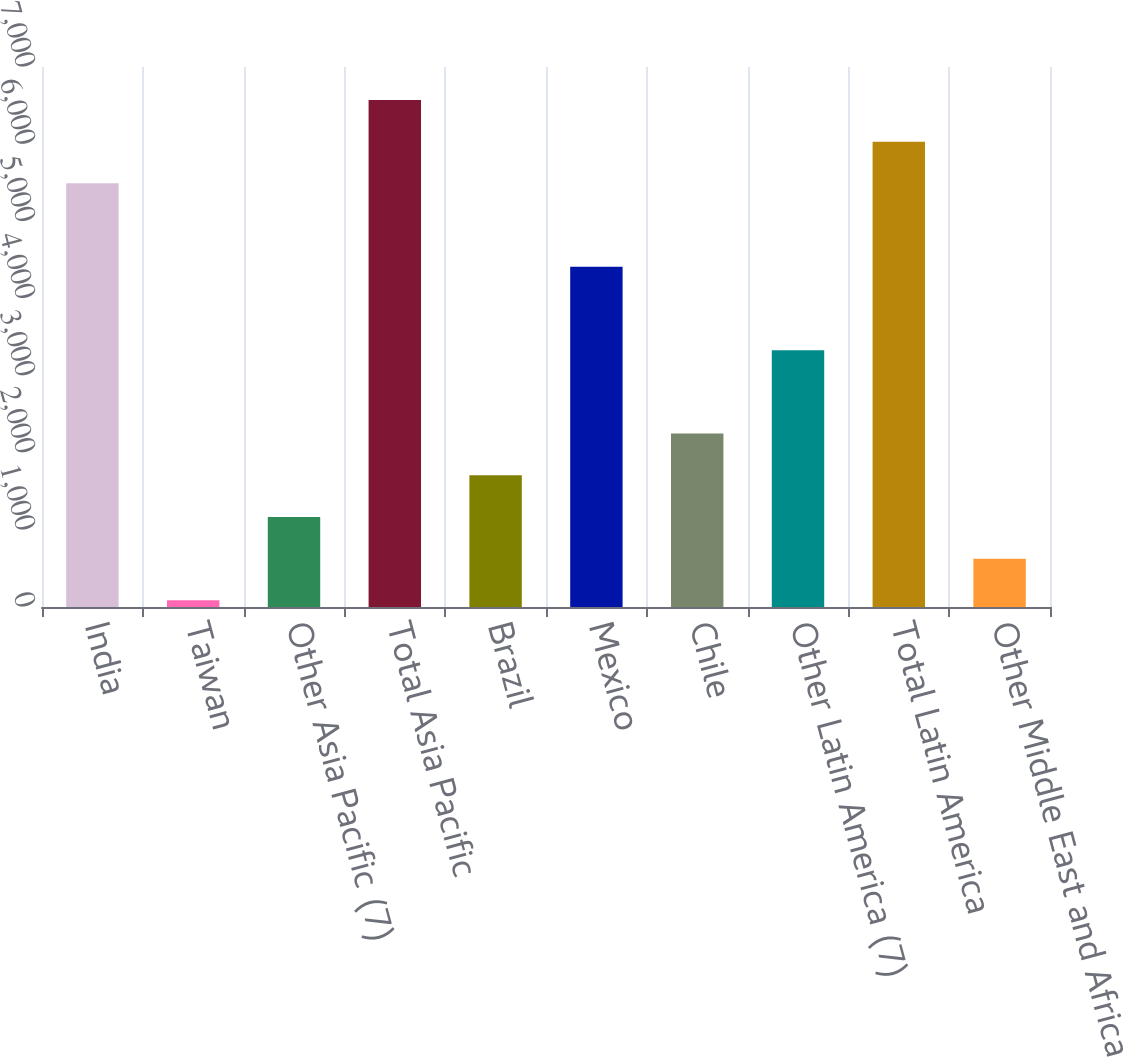Convert chart to OTSL. <chart><loc_0><loc_0><loc_500><loc_500><bar_chart><fcel>India<fcel>Taiwan<fcel>Other Asia Pacific (7)<fcel>Total Asia Pacific<fcel>Brazil<fcel>Mexico<fcel>Chile<fcel>Other Latin America (7)<fcel>Total Latin America<fcel>Other Middle East and Africa<nl><fcel>5492<fcel>86<fcel>1167.2<fcel>6573.2<fcel>1707.8<fcel>4410.8<fcel>2248.4<fcel>3329.6<fcel>6032.6<fcel>626.6<nl></chart> 